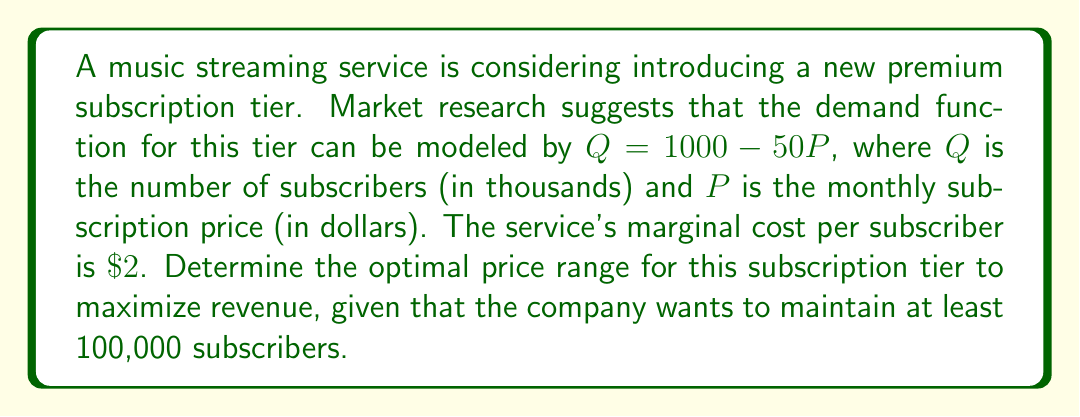Could you help me with this problem? 1) First, we need to set up the revenue function. Revenue is price times quantity:
   $R = PQ = P(1000 - 50P) = 1000P - 50P^2$

2) To find the maximum revenue, we differentiate R with respect to P and set it to zero:
   $\frac{dR}{dP} = 1000 - 100P = 0$
   $100P = 1000$
   $P = 10$

3) This gives us the price that maximizes revenue. At $P = 10$, $Q = 1000 - 50(10) = 500$ thousand subscribers.

4) However, we need to consider the constraint of maintaining at least 100,000 subscribers:
   $Q \geq 100$
   $1000 - 50P \geq 100$
   $900 \geq 50P$
   $P \leq 18$

5) We also need to ensure the price is above the marginal cost of $\$2$:
   $P > 2$

6) Therefore, our optimal price range is $2 < P \leq 18$.

7) To refine this further, we can calculate the profit at the revenue-maximizing price:
   At $P = 10$: Profit = $10 * 500,000 - 2 * 500,000 = 4,000,000$

8) This profit is higher than at the extremes of our range:
   At $P = 18$: Profit = $18 * 100,000 - 2 * 100,000 = 1,600,000$
   At $P$ just above $2$: Profit approaches 0

Therefore, the optimal price range should be centered around $\$10$, perhaps $\$8$ to $\$12$ to allow for some flexibility while staying well above the marginal cost and maintaining sufficient subscriber numbers.
Answer: $\$8$ to $\$12$ 